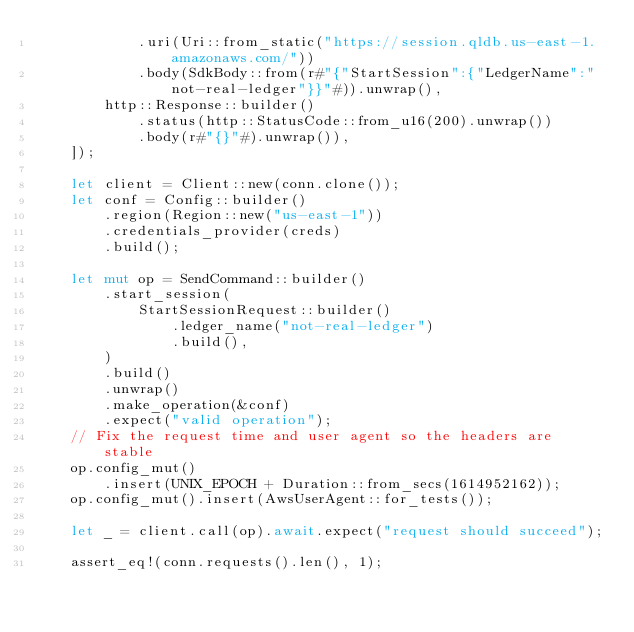<code> <loc_0><loc_0><loc_500><loc_500><_Rust_>            .uri(Uri::from_static("https://session.qldb.us-east-1.amazonaws.com/"))
            .body(SdkBody::from(r#"{"StartSession":{"LedgerName":"not-real-ledger"}}"#)).unwrap(),
        http::Response::builder()
            .status(http::StatusCode::from_u16(200).unwrap())
            .body(r#"{}"#).unwrap()),
    ]);

    let client = Client::new(conn.clone());
    let conf = Config::builder()
        .region(Region::new("us-east-1"))
        .credentials_provider(creds)
        .build();

    let mut op = SendCommand::builder()
        .start_session(
            StartSessionRequest::builder()
                .ledger_name("not-real-ledger")
                .build(),
        )
        .build()
        .unwrap()
        .make_operation(&conf)
        .expect("valid operation");
    // Fix the request time and user agent so the headers are stable
    op.config_mut()
        .insert(UNIX_EPOCH + Duration::from_secs(1614952162));
    op.config_mut().insert(AwsUserAgent::for_tests());

    let _ = client.call(op).await.expect("request should succeed");

    assert_eq!(conn.requests().len(), 1);</code> 